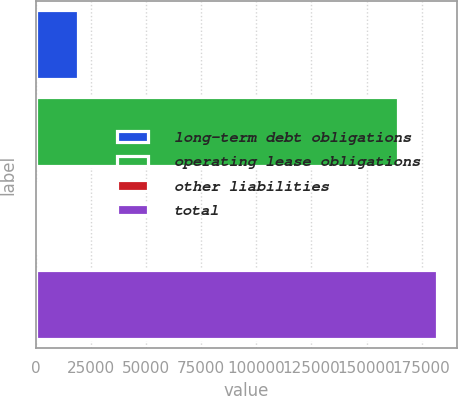Convert chart to OTSL. <chart><loc_0><loc_0><loc_500><loc_500><bar_chart><fcel>long-term debt obligations<fcel>operating lease obligations<fcel>other liabilities<fcel>total<nl><fcel>19019.6<fcel>164103<fcel>1256<fcel>181867<nl></chart> 